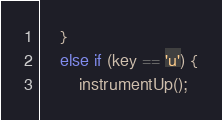Convert code to text. <code><loc_0><loc_0><loc_500><loc_500><_C++_>    }
    else if (key == 'u') {
        instrumentUp();</code> 